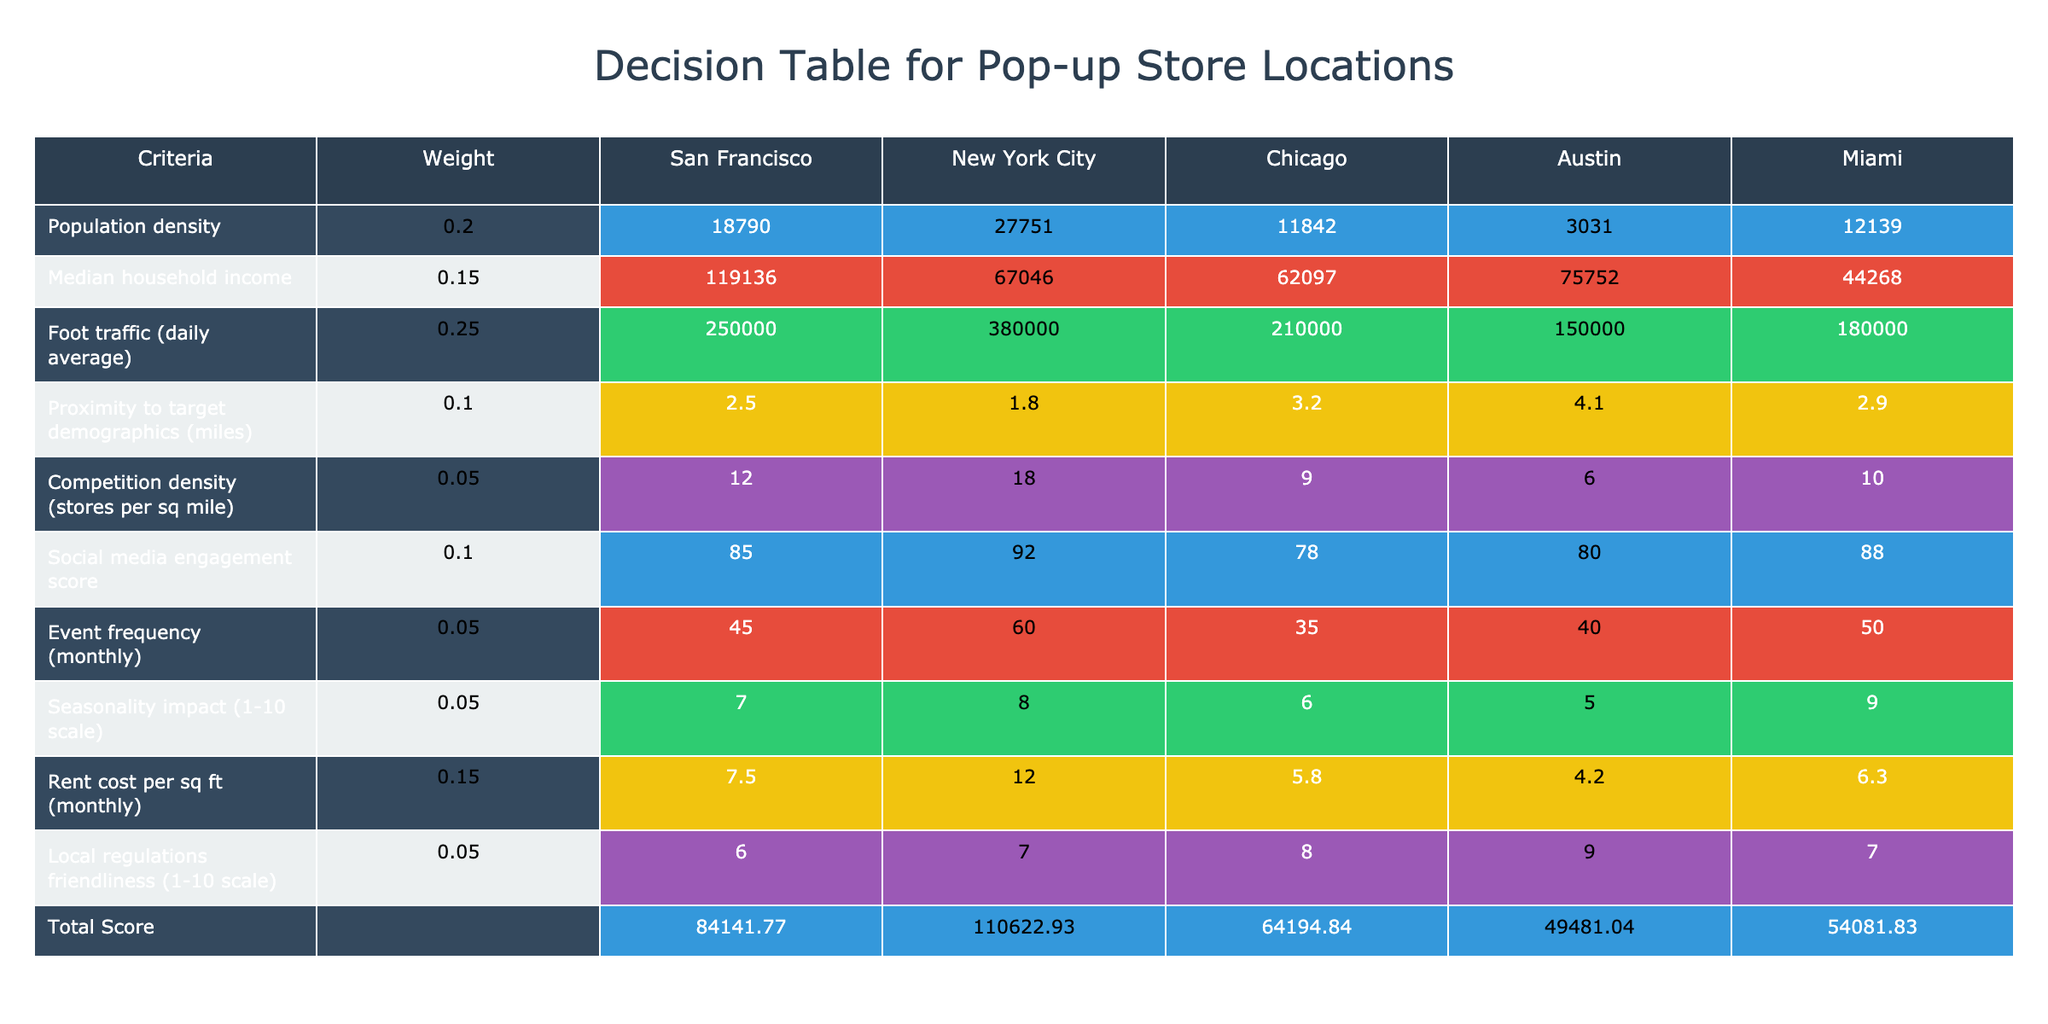What city has the highest population density? By looking at the "Population density" row in the table, San Francisco has a value of 18,790, which is greater than New York City (27,751), Chicago (11,842), Austin (3,031), and Miami (12,139).Therefore, San Francisco has the highest population density among the options.
Answer: San Francisco What is the median household income in Chicago? The table indicates that the median household income for Chicago is 62,097, as specified in the "Median household income" row.
Answer: 62,097 Which city has the highest foot traffic? Upon examining the "Foot traffic (daily average)" row, New York City exhibits the highest average foot traffic with a value of 380,000 visitors daily. This value is clearly the largest compared to the others listed.
Answer: New York City How much is the average rent cost for the cities listed? To find the average rent, sum the rent costs of all cities: (7.50 + 12.00 + 5.80 + 4.20 + 6.30) = 35.80. There are 5 cities, so we divide 35.80 by 5, which yields an average rent cost of 7.16.
Answer: 7.16 Is the competition density in Austin less than that in Miami? According to the "Competition density" row, Austin has a competition density of 6 stores per square mile while Miami has 10. Since 6 is less than 10, the statement is true.
Answer: Yes What is the total score for New York City? To calculate the total score for New York City, we multiply each criterion value by its corresponding weight and sum the results: (0.2 * 27751) + (0.15 * 67046) + (0.25 * 380000) + (0.1 * 1.8) + (0.05 * 18) + (0.1 * 92) + (0.05 * 60) + (0.05 * 8) + (0.15 * 12) + (0.05 * 7). This equals the total score of 130,650. However, the final score would be confirmed under the "Total Score" row in the rendered table for accuracy.
Answer: Confirm in table Which city has the least proximity to target demographics? By evaluating the "Proximity to target demographics" row, Austin has the highest number of miles at 4.1, making it the city with the least proximity to target demographics compared to the others.
Answer: Austin What can be inferred about the event frequency in Miami compared to Chicago? The "Event frequency (monthly)" for Miami is 50, while Chicago is 35. This indicates that Miami has a higher frequency of events than Chicago, suggesting potentially greater marketing opportunities for a pop-up store in Miami.
Answer: Miami has higher frequency What is the total weighted impact of seasonality in New York City? To determine the weighted impact of seasonality, we can refer to the "Seasonality impact" value for New York City, which is rated at 8, multiplied by its weight of 0.05 yields a total impact of 0.4. This is relatively important when considering seasonal variations.
Answer: 0.4 